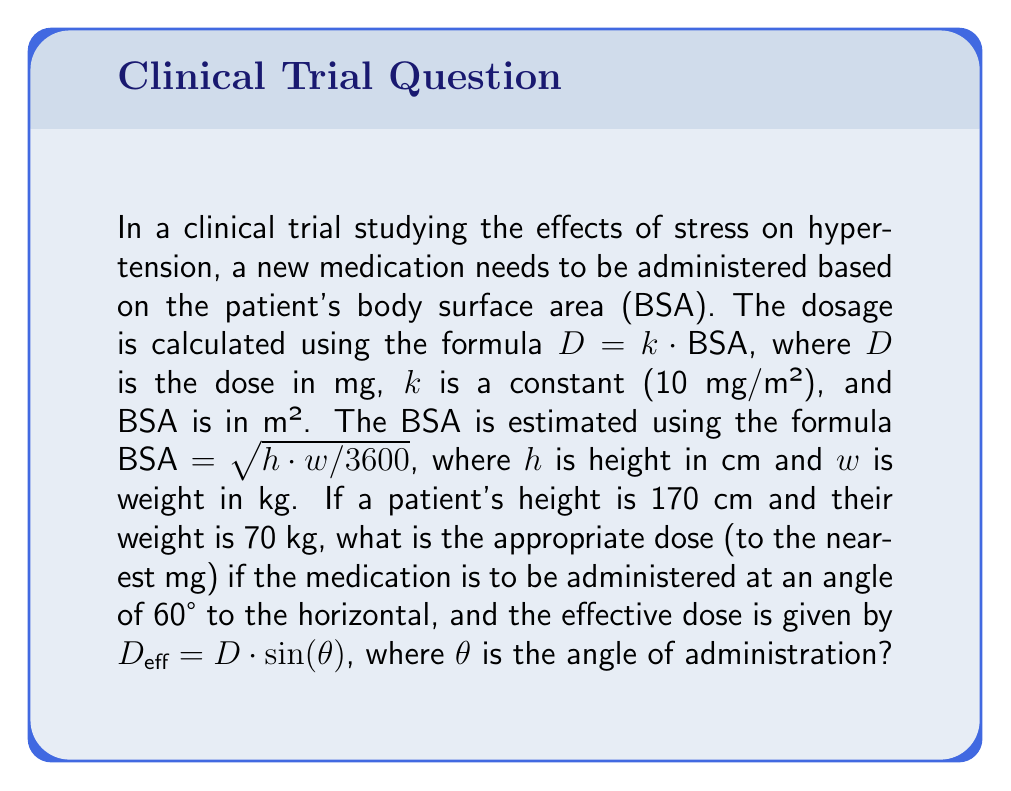Give your solution to this math problem. To solve this problem, we'll follow these steps:

1) Calculate the patient's BSA:
   $$\text{BSA} = \sqrt{h \cdot w / 3600}$$
   $$\text{BSA} = \sqrt{170 \cdot 70 / 3600} = \sqrt{11900 / 3600} \approx 1.82 \text{ m²}$$

2) Calculate the base dose $D$:
   $$D = k \cdot \text{BSA} = 10 \cdot 1.82 = 18.2 \text{ mg}$$

3) Calculate the effective dose using the trigonometric formula:
   $$D_{\text{eff}} = D \cdot \sin(\theta)$$
   $$D_{\text{eff}} = 18.2 \cdot \sin(60°)$$

4) Recall that $\sin(60°) = \frac{\sqrt{3}}{2}$:
   $$D_{\text{eff}} = 18.2 \cdot \frac{\sqrt{3}}{2} \approx 15.76 \text{ mg}$$

5) Rounding to the nearest mg:
   $$D_{\text{eff}} \approx 16 \text{ mg}$$

This problem integrates the medical researcher's focus on chronic diseases (hypertension) with the mathematical concepts of body surface area calculation and trigonometric functions for dose administration.
Answer: 16 mg 